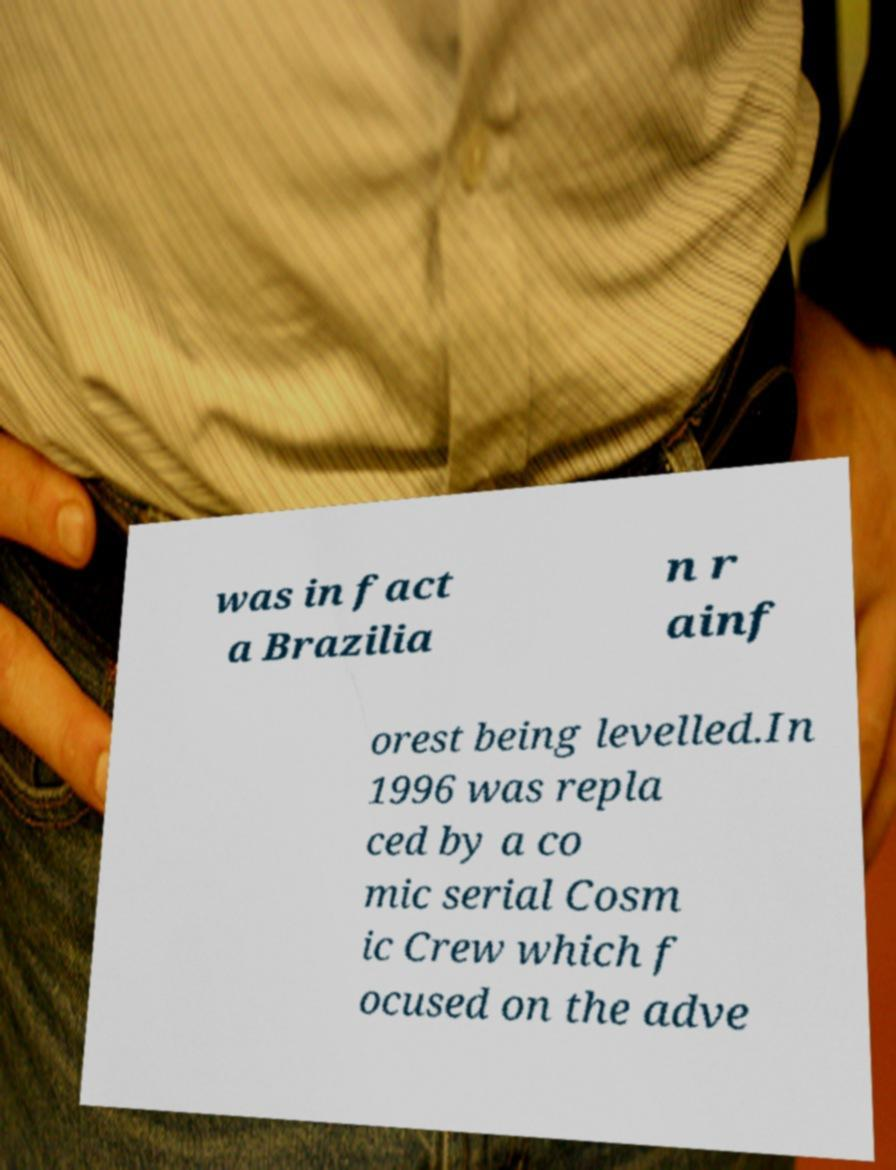Could you extract and type out the text from this image? was in fact a Brazilia n r ainf orest being levelled.In 1996 was repla ced by a co mic serial Cosm ic Crew which f ocused on the adve 